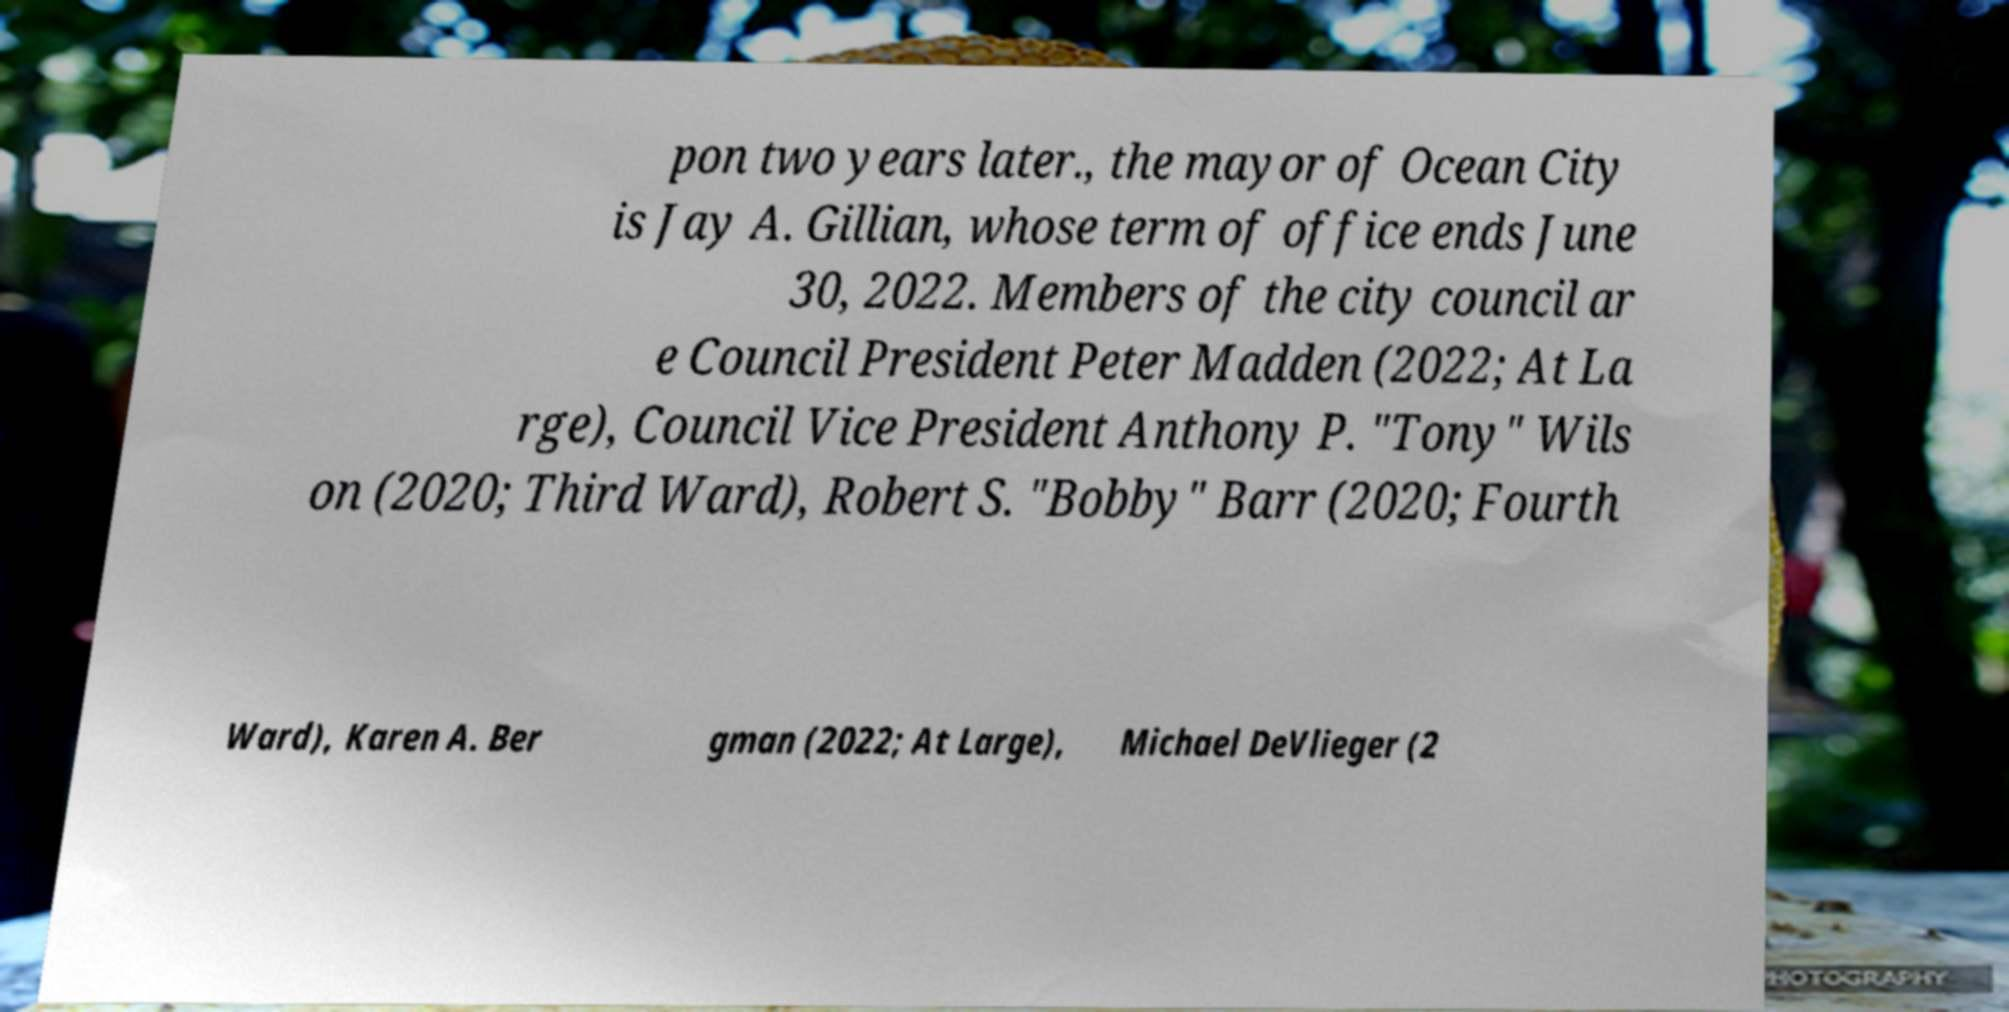For documentation purposes, I need the text within this image transcribed. Could you provide that? pon two years later., the mayor of Ocean City is Jay A. Gillian, whose term of office ends June 30, 2022. Members of the city council ar e Council President Peter Madden (2022; At La rge), Council Vice President Anthony P. "Tony" Wils on (2020; Third Ward), Robert S. "Bobby" Barr (2020; Fourth Ward), Karen A. Ber gman (2022; At Large), Michael DeVlieger (2 